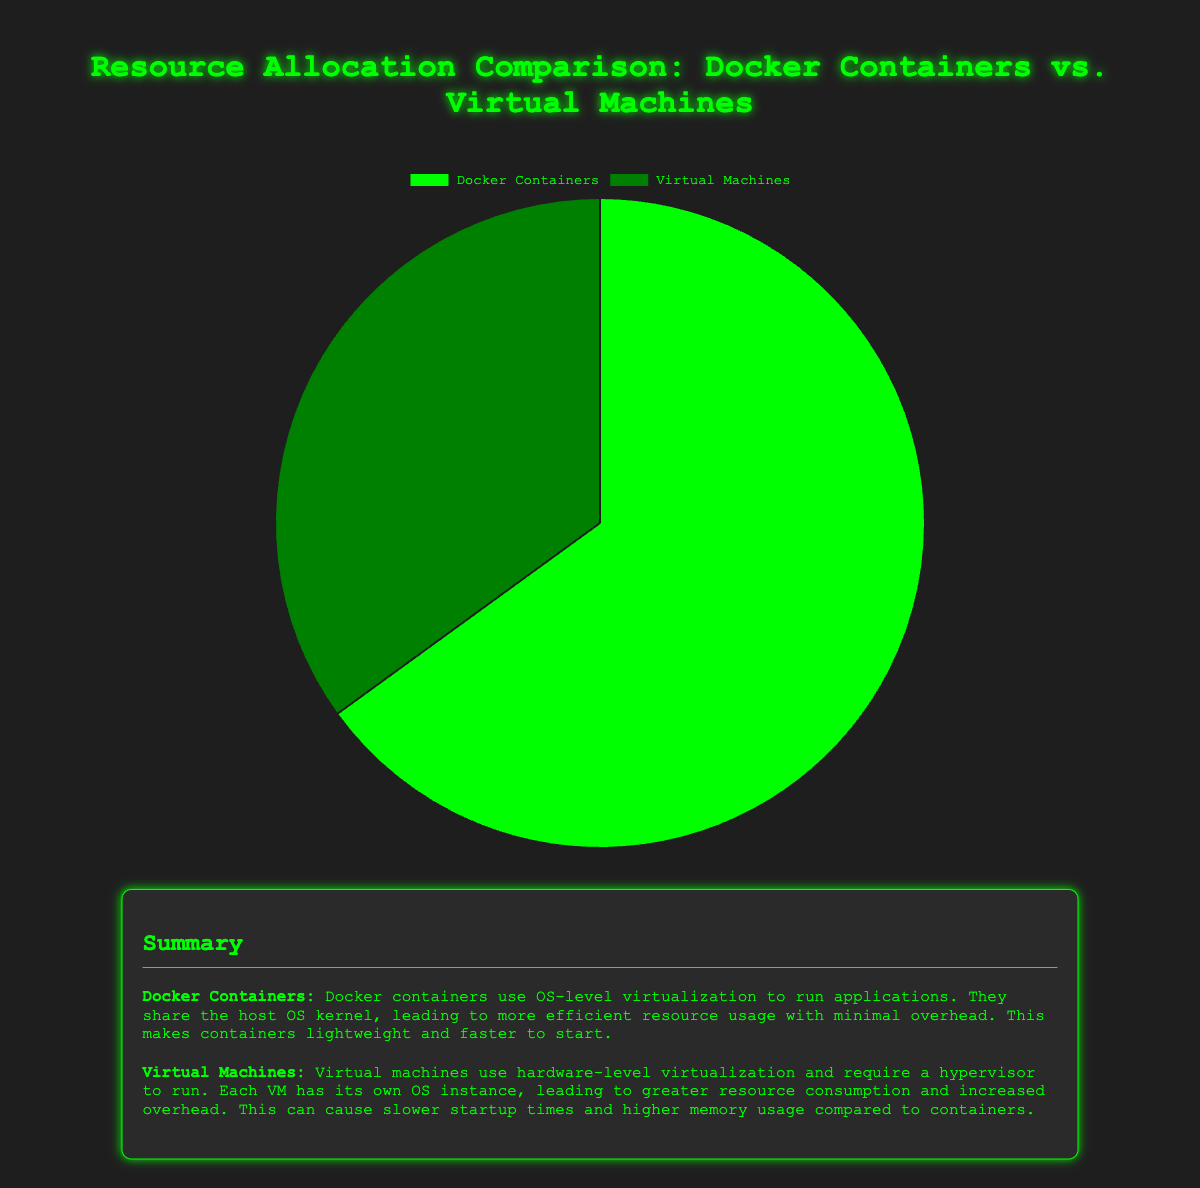What percentage of resources is allocated to Docker Containers? The chart shows that Docker Containers account for 65% of the resource allocation.
Answer: 65% What percentage of resources is allocated to Virtual Machines? The chart shows that Virtual Machines account for 35% of the resource allocation.
Answer: 35% What is the difference in resource allocation between Docker Containers and Virtual Machines? The allocation for Docker Containers is 65%, and for Virtual Machines, it is 35%. The difference is 65% - 35% = 30%.
Answer: 30% Which entity uses more resources, Docker Containers or Virtual Machines? According to the chart, Docker Containers use more resources (65%) compared to Virtual Machines (35%).
Answer: Docker Containers If the total resources available are 100 units, how many units are allocated to Docker Containers? Since Docker Containers use 65% of the resources, they are allocated 65 units (65% of 100).
Answer: 65 units How many units of resources are left for Virtual Machines if the total resources are 100 units? Docker Containers use 65 units out of 100, leaving 100 - 65 = 35 units for Virtual Machines.
Answer: 35 units Which segment of the pie chart is larger by visual comparison? The pie chart segment for Docker Containers is larger than that for Virtual Machines.
Answer: Docker Containers What color represents Docker Containers in the pie chart? The summary and the pie chart legend indicate that Docker Containers are represented in green.
Answer: Green What is the ratio of resources allocated to Docker Containers to those allocated to Virtual Machines? The resources allocated to Docker Containers are 65%, and to Virtual Machines are 35%. Therefore, the ratio is 65:35, which can be simplified to approximately 13:7.
Answer: 13:7 